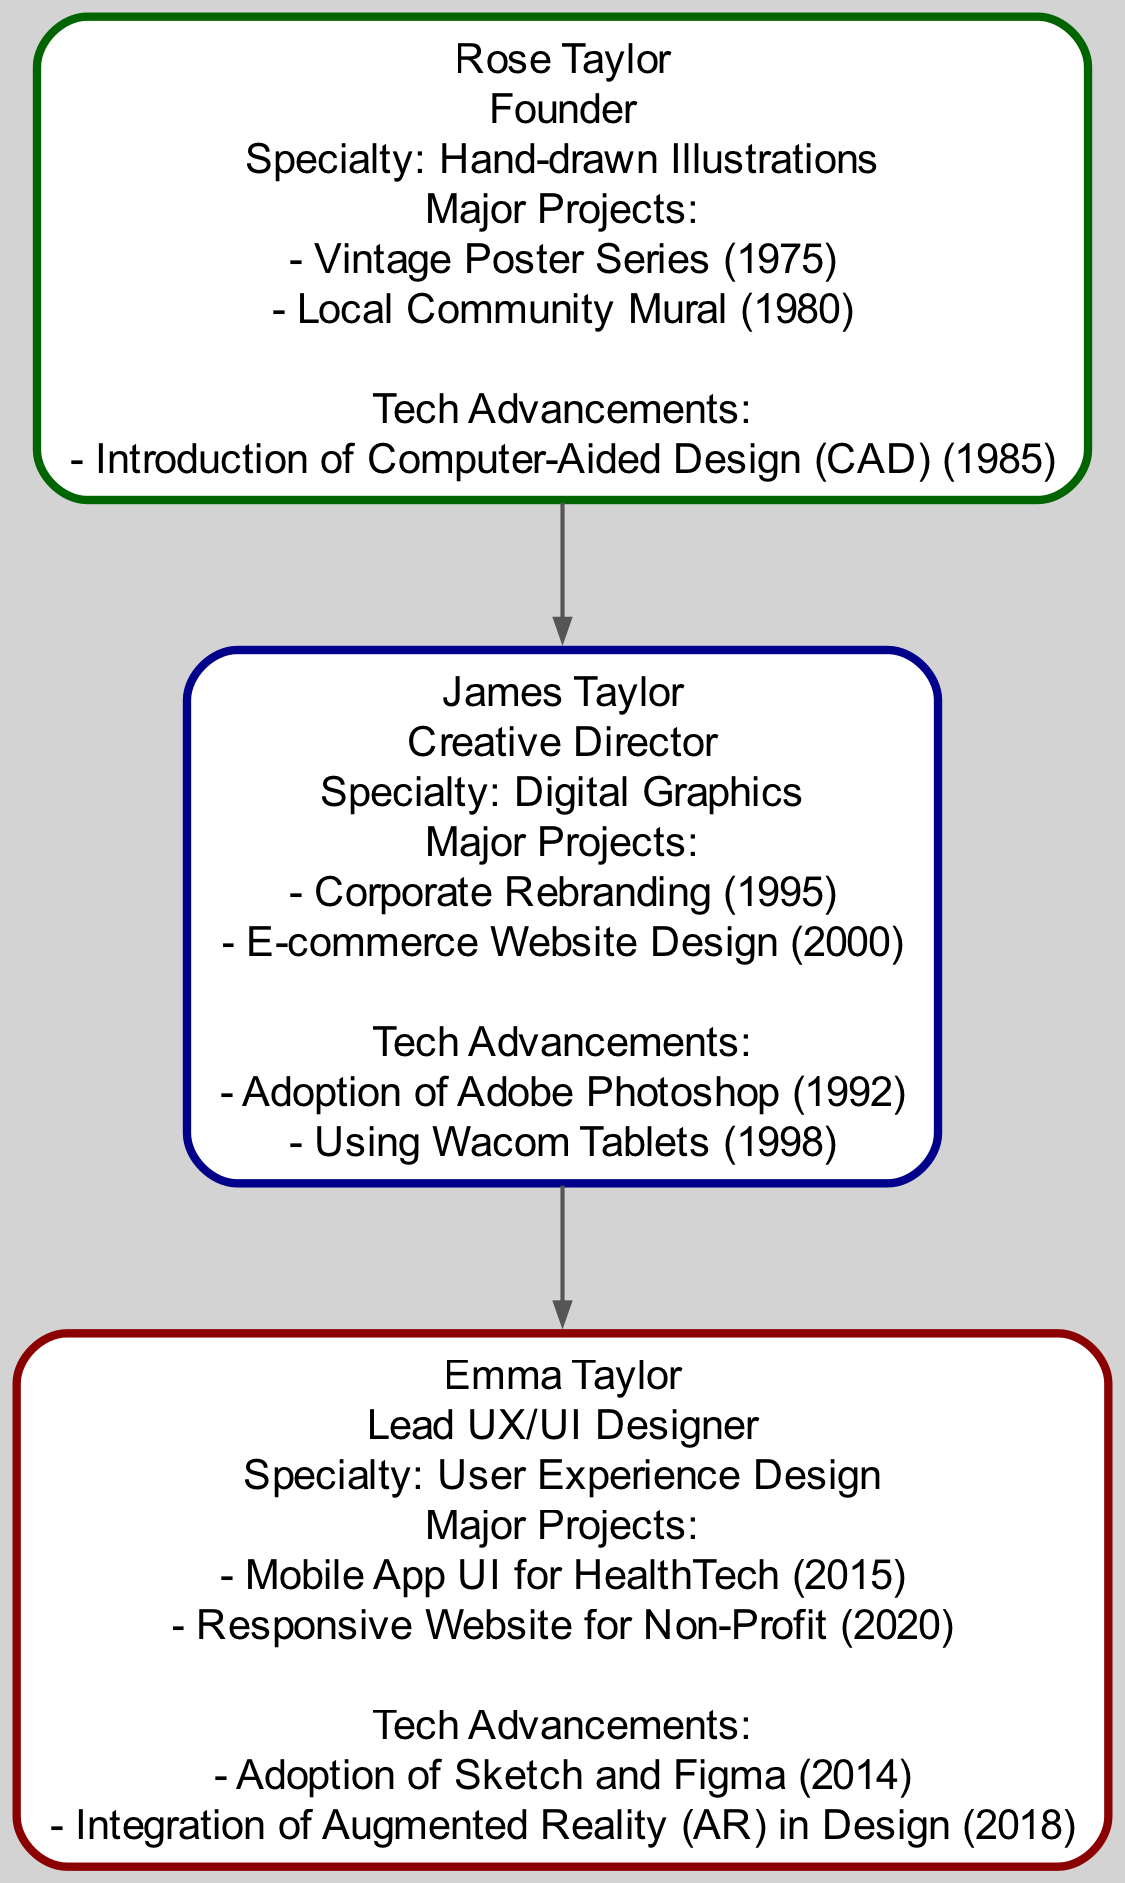What is the name of the founder of the agency? The diagram identifies Rose Taylor as the founder of the design agency, prominently displayed in the founder generation section.
Answer: Rose Taylor How many generations are represented in the family tree? The diagram includes three distinct generations: founder, second generation, and third generation, demonstrating the lineage and evolution within the agency.
Answer: 3 What was the major project completed by James Taylor in 2000? The diagram indicates that the major project completed by James Taylor in 2000 was the "E-commerce Website Design," listed in the creative director's section.
Answer: E-commerce Website Design What technological advancement did Rose Taylor introduce in 1985? The diagram specifies the technological advancement introduced by Rose Taylor in 1985 as the "Introduction of Computer-Aided Design (CAD)," linking it to her founding role.
Answer: Introduction of Computer-Aided Design (CAD) Which software did Emma Taylor adopt in 2014? The diagram points out that Emma Taylor adopted "Sketch and Figma" in 2014, detailing her major technological advancement as a lead UX/UI designer.
Answer: Sketch and Figma What is the specialty of the creative director? According to the diagram, the specialty of the creative director, James Taylor, is "Digital Graphics," which is clearly stated in his section.
Answer: Digital Graphics How many major projects did Emma Taylor work on? The diagram shows that Emma Taylor has worked on two major projects, listed under her section, indicating her contributions in her generation.
Answer: 2 Which technological advancement was made by James Taylor in 1998? The diagram reveals that James Taylor's technological advancement in 1998 was the "Using Wacom Tablets," specifically mentioned in his achievements.
Answer: Using Wacom Tablets What major project was completed by Rose Taylor in 1980? The diagram highlights that the major project completed by Rose Taylor in 1980 was the "Local Community Mural," detailing an important milestone in her founding years.
Answer: Local Community Mural 